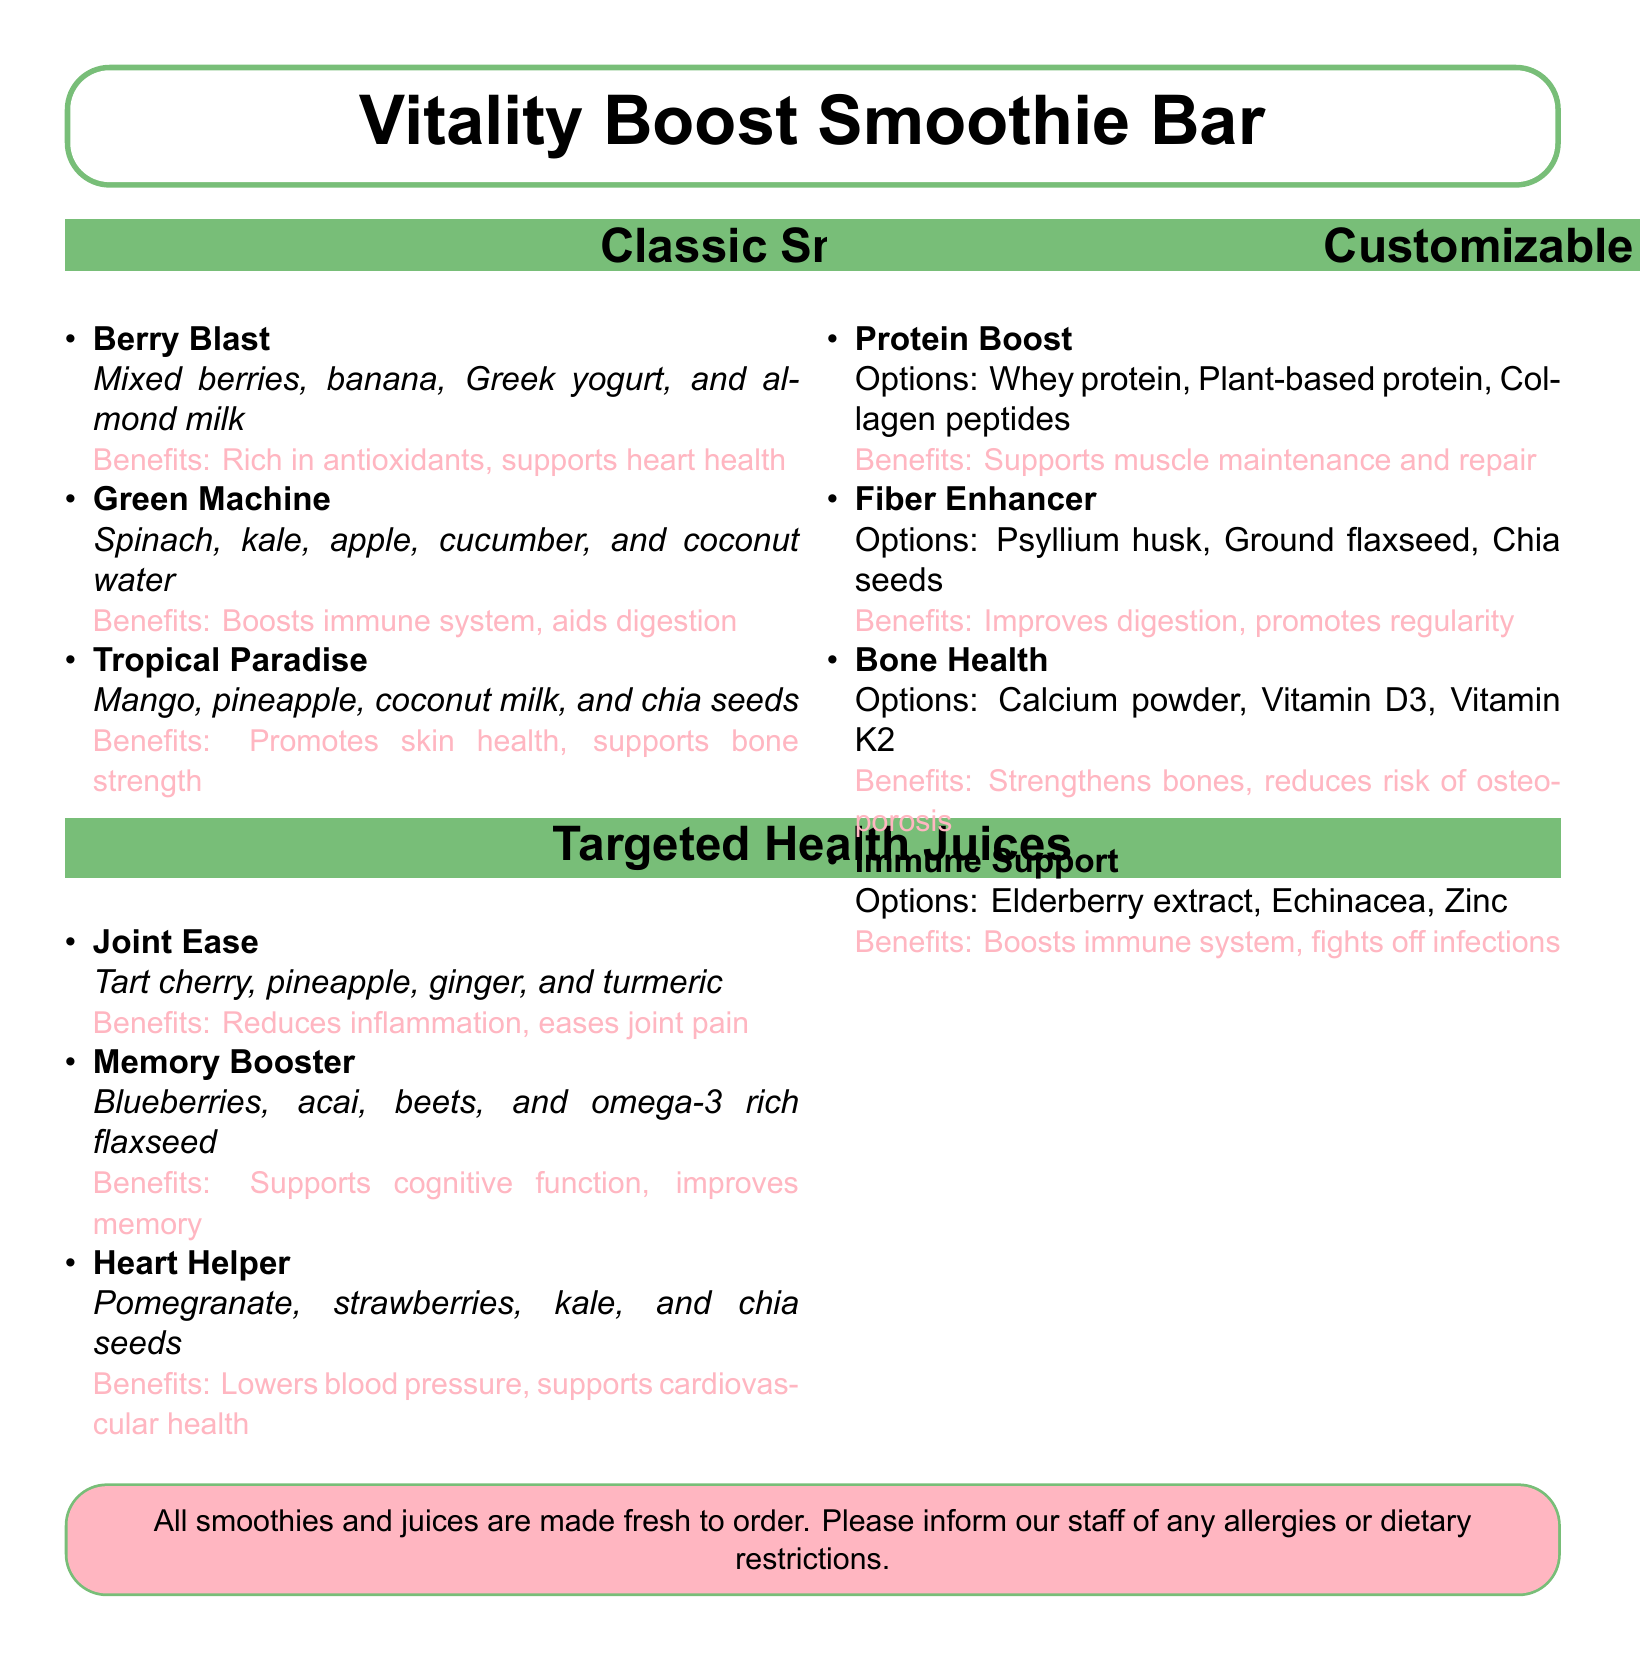What are the names of the classic smoothies? The classic smoothies listed are Berry Blast, Green Machine, and Tropical Paradise.
Answer: Berry Blast, Green Machine, Tropical Paradise What is the main ingredient in the Joint Ease juice? The main ingredients in Joint Ease juice are tart cherry, pineapple, ginger, and turmeric.
Answer: Tart cherry Which add-in supports muscle maintenance? The add-in that supports muscle maintenance is protein boost.
Answer: Protein Boost How many targeted health juices are listed? There are a total of three targeted health juices mentioned in the document.
Answer: 3 What benefits does the Fiber Enhancer provide? The Fiber Enhancer improves digestion and promotes regularity.
Answer: Improves digestion, promotes regularity What is the purpose of the Bone Health add-in? The purpose of the Bone Health add-in is to strengthen bones and reduce the risk of osteoporosis.
Answer: Strengthens bones, reduces risk of osteoporosis What color is used for the Classic Smoothies section title? The color used for the Classic Smoothies section title is smoothie green.
Answer: Smoothie green Which two add-ins are associated with immune system support? The two add-ins associated with immune system support are elderberry extract and echinacea.
Answer: Elderberry extract, Echinacea What type of establishment is this document for? This document is for a smoothie and juice bar menu.
Answer: Smoothie and juice bar 